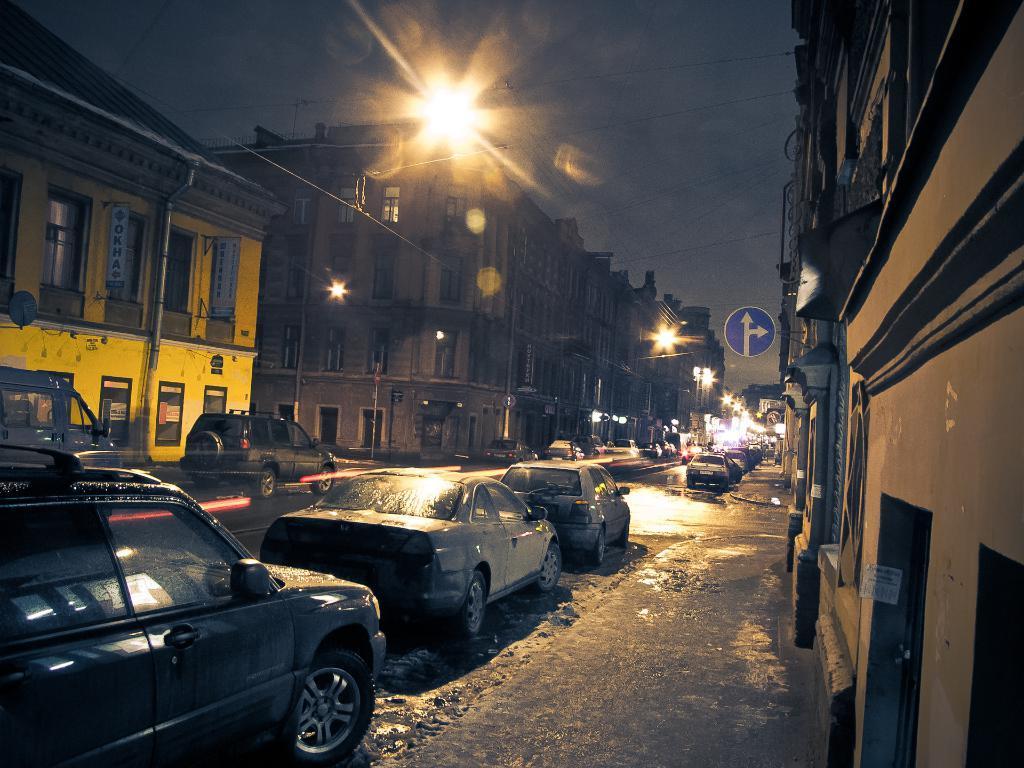In one or two sentences, can you explain what this image depicts? In this image we can see buildings, street poles, sign boards, pipelines, information boards, motor vehicles on the road, electric lights and sky. 